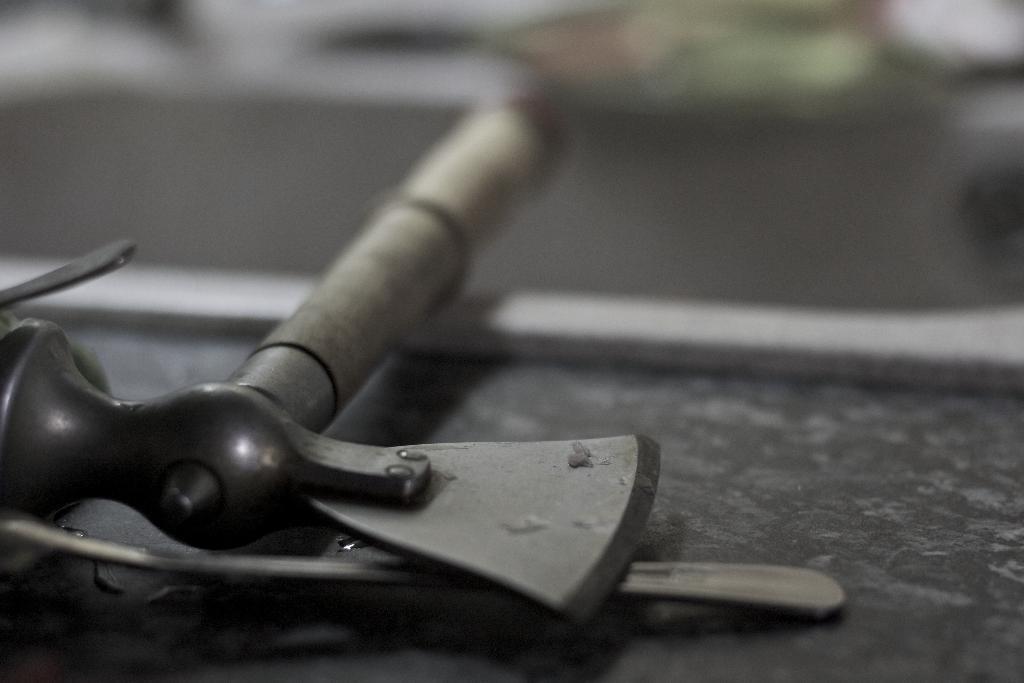Could you give a brief overview of what you see in this image? In this image I can see the axe which is in grey color and it is on the grey color surface. And there is a blurred background. 